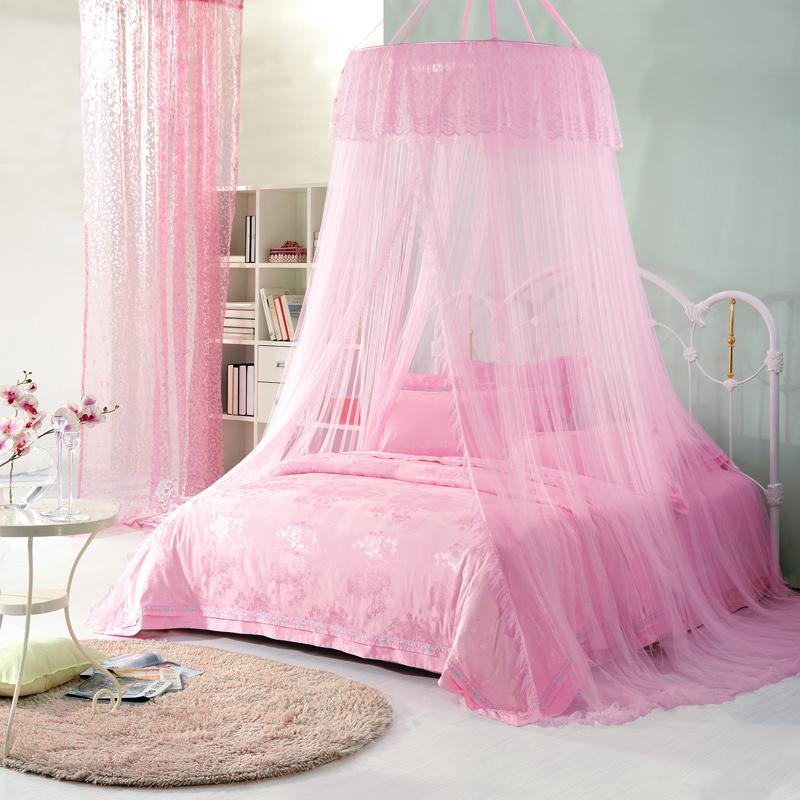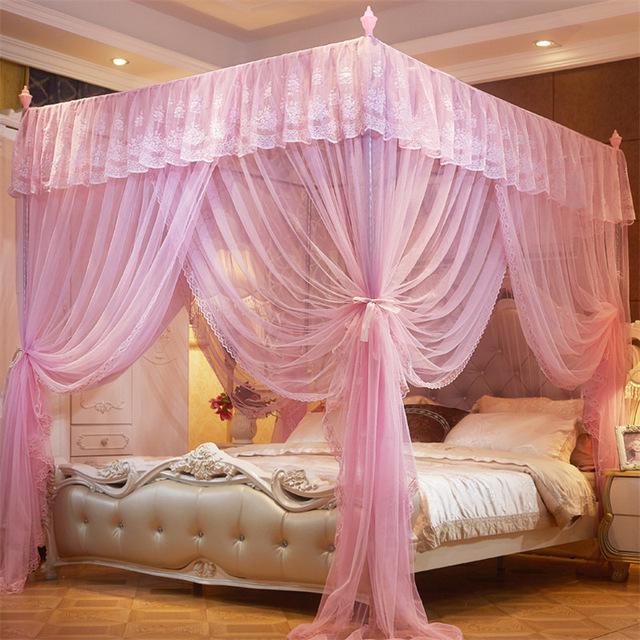The first image is the image on the left, the second image is the image on the right. Analyze the images presented: Is the assertion "The left and right image contains a total of two pink canopies." valid? Answer yes or no. Yes. The first image is the image on the left, the second image is the image on the right. For the images shown, is this caption "All the bed nets are pink." true? Answer yes or no. Yes. 